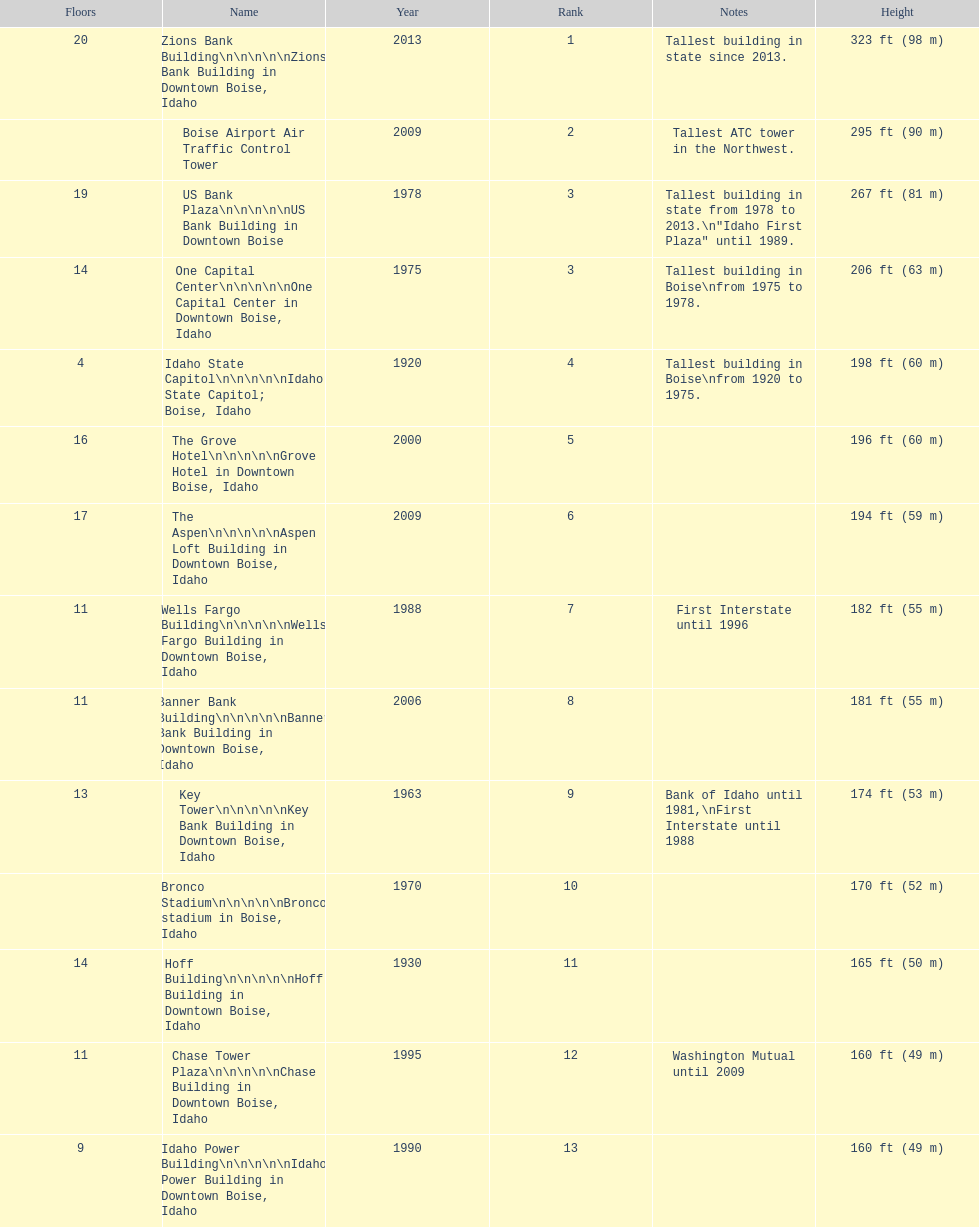How many levels does the tallest structure possess? 20. 